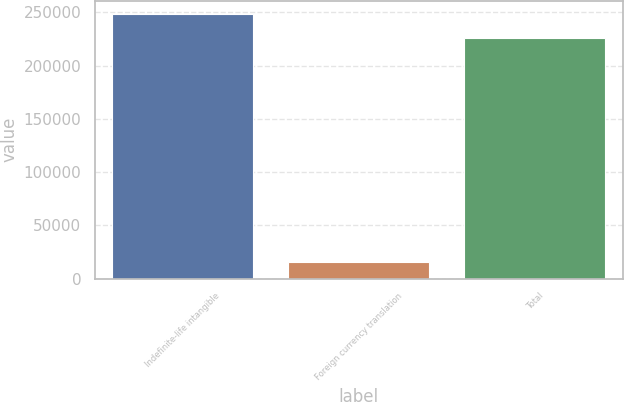Convert chart. <chart><loc_0><loc_0><loc_500><loc_500><bar_chart><fcel>Indefinite-life intangible<fcel>Foreign currency translation<fcel>Total<nl><fcel>248247<fcel>15884<fcel>225679<nl></chart> 